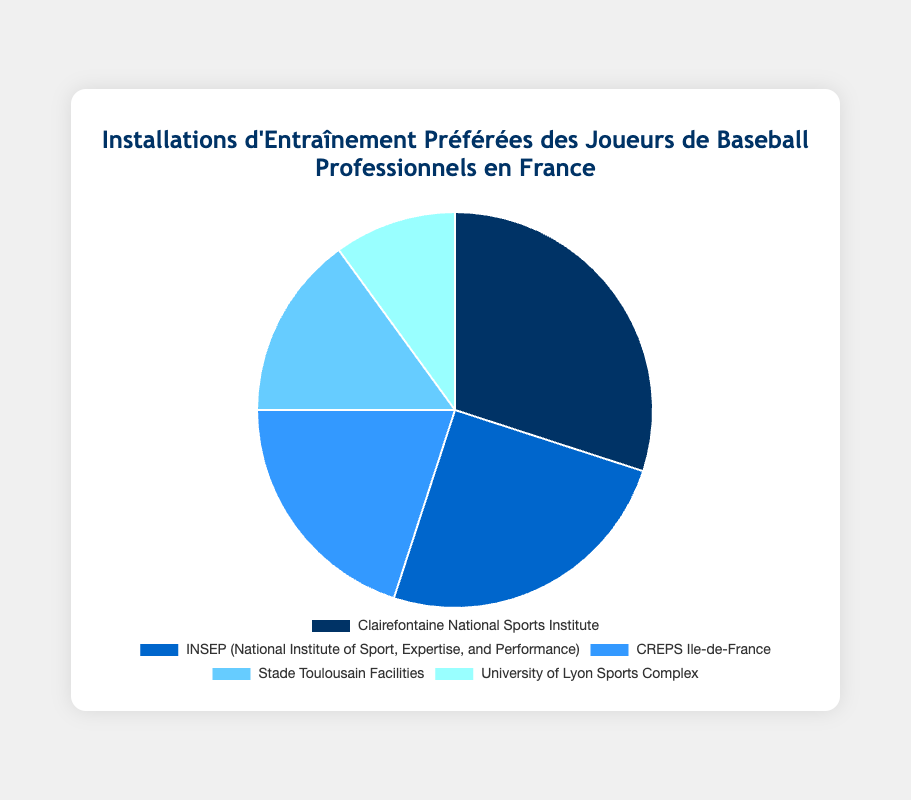Which training facility is the most popular among professional baseball players in France? The Clairefontaine National Sports Institute is the most popular since it represents 30% of the players' preferences, as indicated by the largest segment in the pie chart.
Answer: Clairefontaine National Sports Institute What is the combined percentage of players favoring Clairefontaine National Sports Institute and INSEP? To find the combined percentage, add the percentages for Clairefontaine National Sports Institute (30%) and INSEP (25%). Therefore, 30% + 25% = 55%.
Answer: 55% Which facility is preferred more, Stade Toulousain Facilities or University of Lyon Sports Complex? Comparing the percentages, Stade Toulousain Facilities has 15% whereas University of Lyon Sports Complex has 10%. Therefore, Stade Toulousain Facilities is preferred more.
Answer: Stade Toulousain Facilities What is the percentage difference between the most and least favored training facilities? The most favored facility is Clairefontaine National Sports Institute (30%) and the least favored is University of Lyon Sports Complex (10%). Subtract to find the difference: 30% - 10% = 20%.
Answer: 20% What is the total percentage of players that prefer facilities other than Clairefontaine National Sports Institute? Subtract the percentage of Clairefontaine National Sports Institute (30%) from 100%. Therefore, 100% - 30% = 70%.
Answer: 70% Are there more players that favor CREPS Ile-de-France or players that favor University of Lyon Sports Complex and Stade Toulousain Facilities combined? First, add the percentages of University of Lyon Sports Complex (10%) and Stade Toulousain Facilities (15%): 10% + 15% = 25%. Since CREPS Ile-de-France has 20%, 25% is greater than 20%.
Answer: No Which facilities are represented by shades of blue? The pie segments for Clairefontaine National Sports Institute, INSEP, CREPS Ile-de-France, and Stade Toulousain Facilities are in varying shades of blue according to the legend and pie chart colors.
Answer: Clairefontaine National Sports Institute, INSEP, CREPS Ile-de-France, Stade Toulousain Facilities If the percentages for each facility represent the number of votes, how many more votes did Clairefontaine National Sports Institute receive than the University of Lyon Sports Complex? Assuming percentages are out of 100 total votes, Clairefontaine has 30 votes, and the University of Lyon has 10 votes. The difference is 30 - 10 = 20 votes.
Answer: 20 votes 